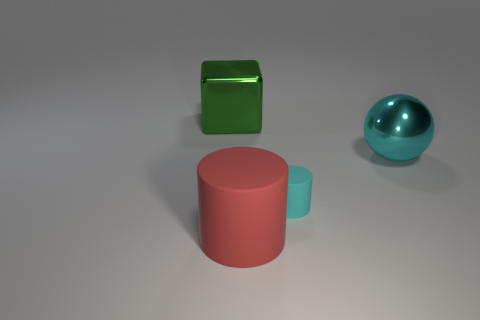The other cylinder that is the same material as the red cylinder is what size?
Give a very brief answer. Small. What size is the cyan cylinder?
Offer a terse response. Small. The small rubber thing is what shape?
Make the answer very short. Cylinder. Do the large metallic object in front of the metal cube and the large cube have the same color?
Your response must be concise. No. What is the size of the other object that is the same shape as the small rubber thing?
Keep it short and to the point. Large. Is there anything else that has the same material as the big red thing?
Keep it short and to the point. Yes. There is a big metallic object to the right of the metallic object behind the large cyan ball; is there a cyan metallic sphere that is in front of it?
Your answer should be compact. No. What is the cyan thing that is to the right of the cyan matte cylinder made of?
Provide a short and direct response. Metal. What number of large things are red rubber things or green blocks?
Give a very brief answer. 2. Is the size of the rubber cylinder that is right of the red cylinder the same as the shiny cube?
Offer a very short reply. No. 